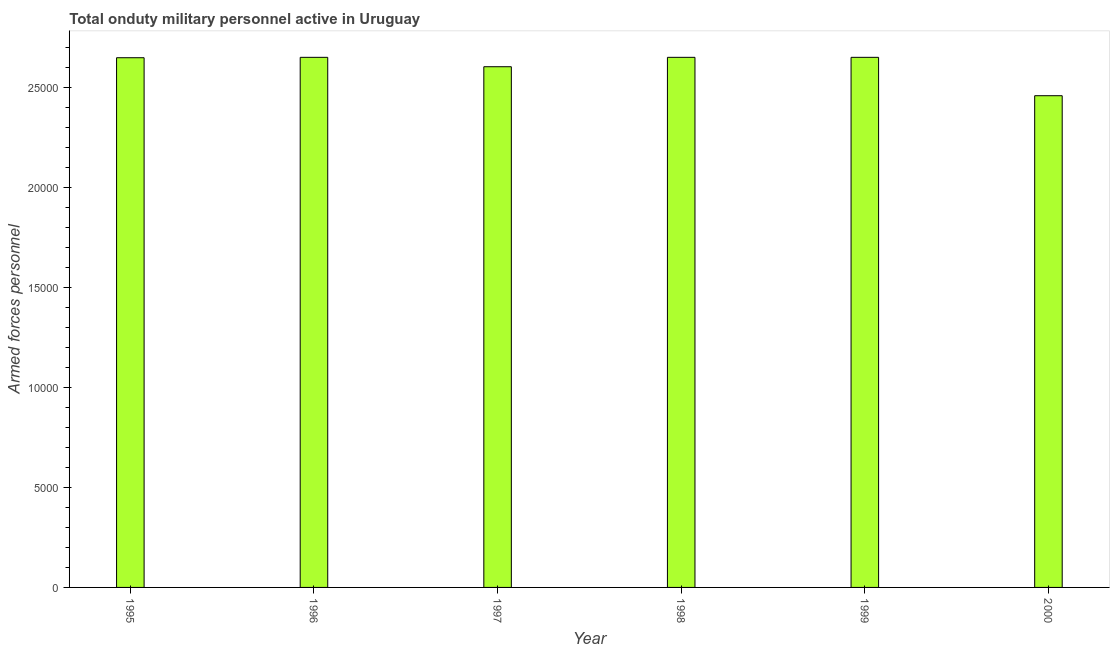Does the graph contain grids?
Your response must be concise. No. What is the title of the graph?
Offer a terse response. Total onduty military personnel active in Uruguay. What is the label or title of the Y-axis?
Offer a very short reply. Armed forces personnel. What is the number of armed forces personnel in 1995?
Offer a terse response. 2.65e+04. Across all years, what is the maximum number of armed forces personnel?
Give a very brief answer. 2.65e+04. Across all years, what is the minimum number of armed forces personnel?
Ensure brevity in your answer.  2.46e+04. In which year was the number of armed forces personnel maximum?
Make the answer very short. 1996. In which year was the number of armed forces personnel minimum?
Keep it short and to the point. 2000. What is the sum of the number of armed forces personnel?
Offer a terse response. 1.57e+05. What is the difference between the number of armed forces personnel in 1999 and 2000?
Ensure brevity in your answer.  1920. What is the average number of armed forces personnel per year?
Your answer should be very brief. 2.61e+04. What is the median number of armed forces personnel?
Make the answer very short. 2.65e+04. In how many years, is the number of armed forces personnel greater than 13000 ?
Your answer should be very brief. 6. What is the ratio of the number of armed forces personnel in 1995 to that in 1996?
Offer a very short reply. 1. What is the difference between the highest and the lowest number of armed forces personnel?
Make the answer very short. 1920. How many bars are there?
Offer a very short reply. 6. How many years are there in the graph?
Make the answer very short. 6. Are the values on the major ticks of Y-axis written in scientific E-notation?
Keep it short and to the point. No. What is the Armed forces personnel in 1995?
Your answer should be very brief. 2.65e+04. What is the Armed forces personnel in 1996?
Offer a terse response. 2.65e+04. What is the Armed forces personnel in 1997?
Your answer should be very brief. 2.60e+04. What is the Armed forces personnel of 1998?
Give a very brief answer. 2.65e+04. What is the Armed forces personnel in 1999?
Your answer should be compact. 2.65e+04. What is the Armed forces personnel in 2000?
Your answer should be compact. 2.46e+04. What is the difference between the Armed forces personnel in 1995 and 1997?
Keep it short and to the point. 450. What is the difference between the Armed forces personnel in 1995 and 1999?
Provide a short and direct response. -20. What is the difference between the Armed forces personnel in 1995 and 2000?
Keep it short and to the point. 1900. What is the difference between the Armed forces personnel in 1996 and 1997?
Ensure brevity in your answer.  470. What is the difference between the Armed forces personnel in 1996 and 1998?
Your answer should be very brief. 0. What is the difference between the Armed forces personnel in 1996 and 1999?
Offer a terse response. 0. What is the difference between the Armed forces personnel in 1996 and 2000?
Give a very brief answer. 1920. What is the difference between the Armed forces personnel in 1997 and 1998?
Provide a succinct answer. -470. What is the difference between the Armed forces personnel in 1997 and 1999?
Offer a terse response. -470. What is the difference between the Armed forces personnel in 1997 and 2000?
Provide a succinct answer. 1450. What is the difference between the Armed forces personnel in 1998 and 2000?
Your answer should be compact. 1920. What is the difference between the Armed forces personnel in 1999 and 2000?
Offer a very short reply. 1920. What is the ratio of the Armed forces personnel in 1995 to that in 1997?
Provide a short and direct response. 1.02. What is the ratio of the Armed forces personnel in 1995 to that in 1998?
Offer a terse response. 1. What is the ratio of the Armed forces personnel in 1995 to that in 2000?
Offer a very short reply. 1.08. What is the ratio of the Armed forces personnel in 1996 to that in 1997?
Provide a short and direct response. 1.02. What is the ratio of the Armed forces personnel in 1996 to that in 1998?
Provide a succinct answer. 1. What is the ratio of the Armed forces personnel in 1996 to that in 2000?
Offer a terse response. 1.08. What is the ratio of the Armed forces personnel in 1997 to that in 1998?
Provide a succinct answer. 0.98. What is the ratio of the Armed forces personnel in 1997 to that in 2000?
Keep it short and to the point. 1.06. What is the ratio of the Armed forces personnel in 1998 to that in 2000?
Provide a short and direct response. 1.08. What is the ratio of the Armed forces personnel in 1999 to that in 2000?
Offer a very short reply. 1.08. 